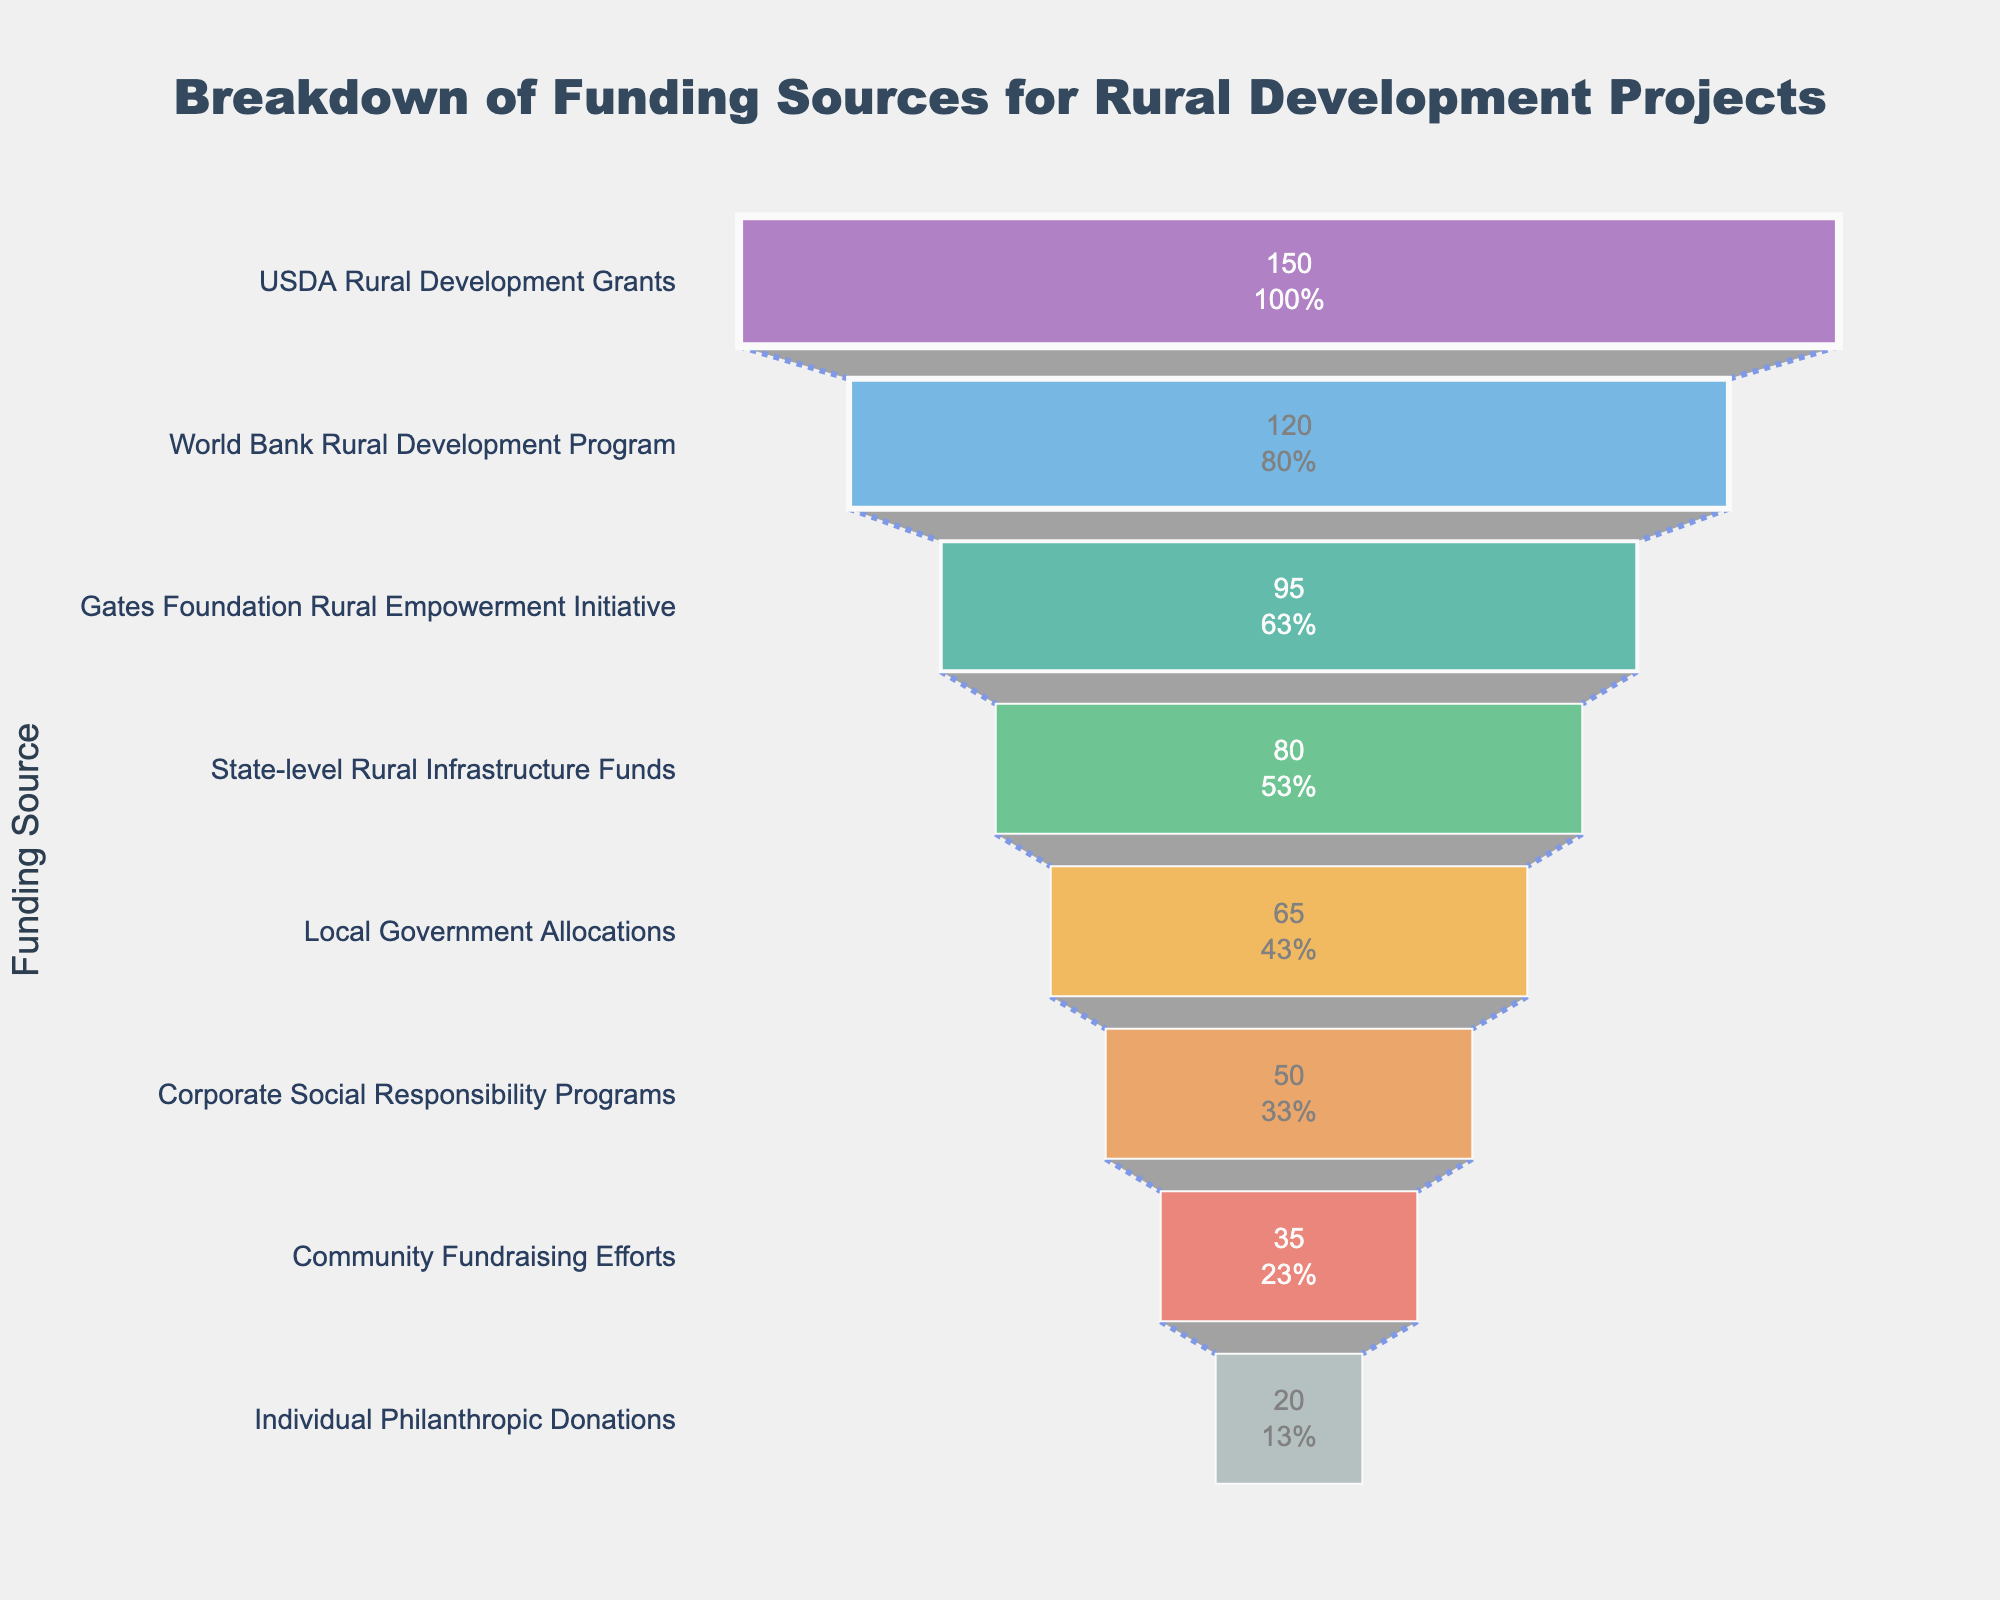What's the title of the funnel chart? The title is located at the top of the chart. It reads: "Breakdown of Funding Sources for Rural Development Projects."
Answer: Breakdown of Funding Sources for Rural Development Projects Which funding source contributes the highest amount? The first, and largest, section of the funnel chart represents the greatest amount. It is labeled "USDA Rural Development Grants" with an amount of 150 million USD.
Answer: USDA Rural Development Grants How much funding is provided by the Gates Foundation Rural Empowerment Initiative? Located in the third section from the top, the Gates Foundation Rural Empowerment Initiative is labeled with the amount of 95 million USD.
Answer: 95 million USD Rank the top three funding sources in terms of amount. The top three sections of the funnel chart, from largest to smallest, are USDA Rural Development Grants (150 million USD), World Bank Rural Development Program (120 million USD), and Gates Foundation Rural Empowerment Initiative (95 million USD).
Answer: USDA Rural Development Grants, World Bank Rural Development Program, Gates Foundation Rural Empowerment Initiative What is the total funding contributed by Local Government Allocations and Corporate Social Responsibility Programs? Locate both sections on the funnel chart. They are labeled "Local Government Allocations" (65 million USD) and "Corporate Social Responsibility Programs" (50 million USD). Adding these amounts gives 65 + 50 = 115 million USD.
Answer: 115 million USD How does the amount from Individual Philanthropic Donations compare to Community Fundraising Efforts? Individual Philanthropic Donations, at 20 million USD, is less than Community Fundraising Efforts, which is 35 million USD, by 15 million USD.
Answer: 20 million USD less Which funding source is positioned fourth in the funnel chart? The fourth section from the top of the funnel chart represents "State-level Rural Infrastructure Funds" with an amount of 80 million USD.
Answer: State-level Rural Infrastructure Funds What percentage of the total initial amount is contributed by State-level Rural Infrastructure Funds? First, sum the total of all funding sources: 150 + 120 + 95 + 80 + 65 + 50 + 35 + 20 = 615 million USD. State-level Rural Infrastructure Funds contribute 80 million USD. The percentage is calculated as (80/615) * 100% ≈ 13%.
Answer: 13% How much more funding is provided by USDA Rural Development Grants compared to Local Government Allocations? USDA Rural Development Grants have 150 million USD, while Local Government Allocations have 65 million USD. The difference is 150 - 65 = 85 million USD.
Answer: 85 million USD Which funding source has the least amount contributed and what is its value? The smallest section at the bottom of the funnel chart represents "Individual Philanthropic Donations" with an amount of 20 million USD.
Answer: Individual Philanthropic Donations, 20 million USD 